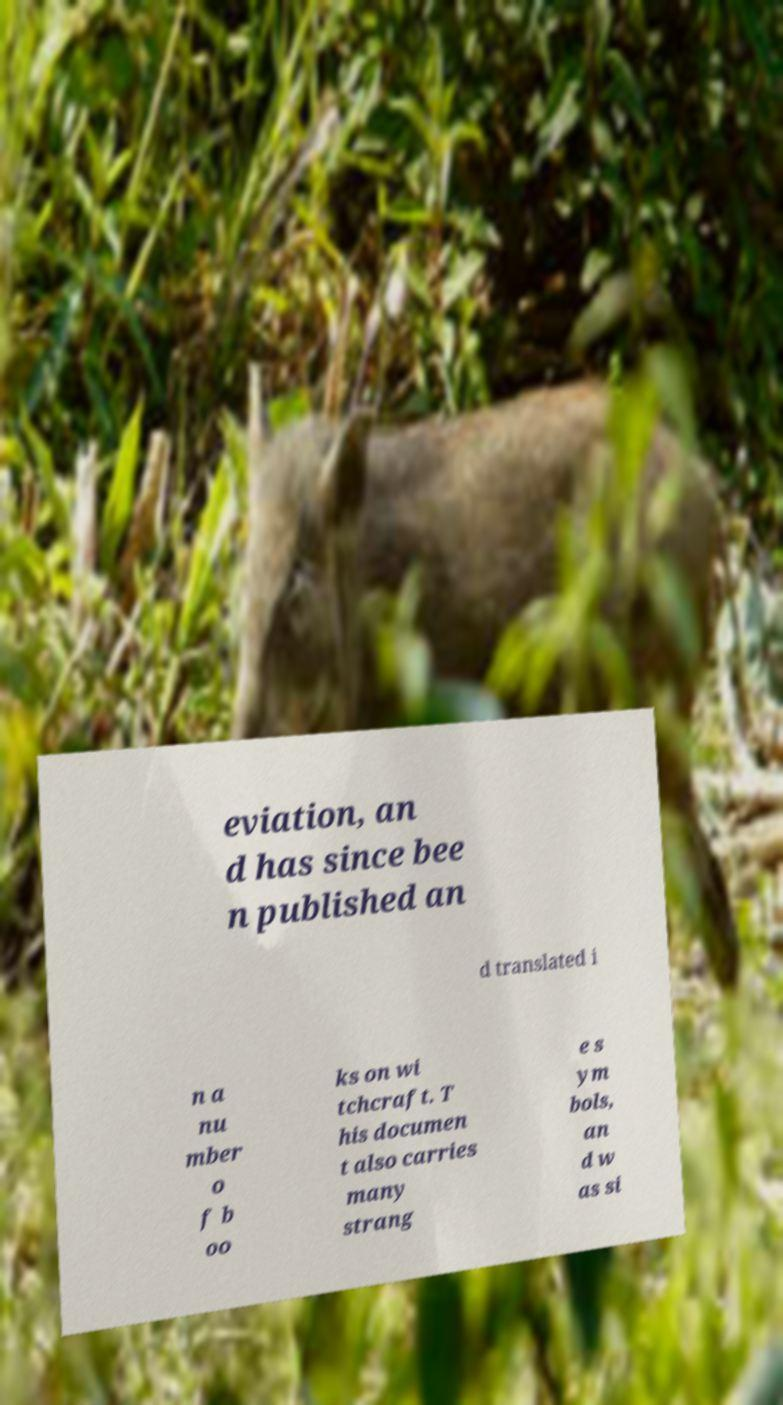Could you assist in decoding the text presented in this image and type it out clearly? eviation, an d has since bee n published an d translated i n a nu mber o f b oo ks on wi tchcraft. T his documen t also carries many strang e s ym bols, an d w as si 